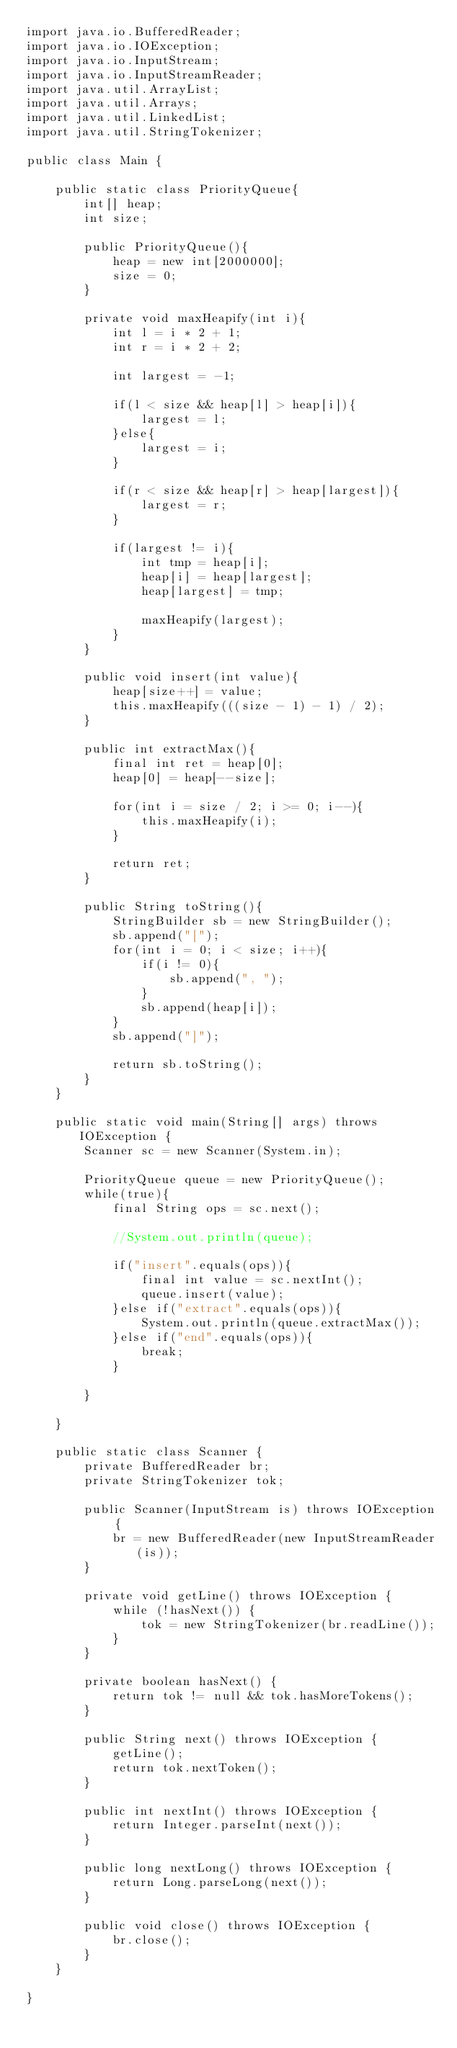<code> <loc_0><loc_0><loc_500><loc_500><_Java_>import java.io.BufferedReader;
import java.io.IOException;
import java.io.InputStream;
import java.io.InputStreamReader;
import java.util.ArrayList;
import java.util.Arrays;
import java.util.LinkedList;
import java.util.StringTokenizer;

public class Main {
	
	public static class PriorityQueue{
		int[] heap;
		int size;
		
		public PriorityQueue(){
			heap = new int[2000000];
			size = 0;
		}
		
		private void maxHeapify(int i){
			int l = i * 2 + 1;
			int r = i * 2 + 2;
		
			int largest = -1;
		
			if(l < size && heap[l] > heap[i]){
				largest = l;
			}else{
				largest = i;
			}
		
			if(r < size && heap[r] > heap[largest]){
				largest = r;
			}
		
			if(largest != i){
				int tmp = heap[i];
				heap[i] = heap[largest];
				heap[largest] = tmp;
			
				maxHeapify(largest);
			}
		}
		
		public void insert(int value){
			heap[size++] = value;
			this.maxHeapify(((size - 1) - 1) / 2);
		}
		
		public int extractMax(){
			final int ret = heap[0];
			heap[0] = heap[--size]; 
			
			for(int i = size / 2; i >= 0; i--){
				this.maxHeapify(i);
			}
			
			return ret;
		}
		
		public String toString(){
			StringBuilder sb = new StringBuilder();
			sb.append("[");
			for(int i = 0; i < size; i++){
				if(i != 0){
					sb.append(", ");
				}
				sb.append(heap[i]);
			}
			sb.append("]");
		
			return sb.toString();
		}
	}
	
	public static void main(String[] args) throws IOException {
		Scanner sc = new Scanner(System.in);
		
		PriorityQueue queue = new PriorityQueue();
		while(true){
			final String ops = sc.next();
			
			//System.out.println(queue);
			
			if("insert".equals(ops)){
				final int value = sc.nextInt();
				queue.insert(value);
			}else if("extract".equals(ops)){
				System.out.println(queue.extractMax());
			}else if("end".equals(ops)){
				break;
			}
			
		}
		
	}

	public static class Scanner {
		private BufferedReader br;
		private StringTokenizer tok;

		public Scanner(InputStream is) throws IOException {
			br = new BufferedReader(new InputStreamReader(is));
		}

		private void getLine() throws IOException {
			while (!hasNext()) {
				tok = new StringTokenizer(br.readLine());
			}
		}

		private boolean hasNext() {
			return tok != null && tok.hasMoreTokens();
		}

		public String next() throws IOException {
			getLine();
			return tok.nextToken();
		}

		public int nextInt() throws IOException {
			return Integer.parseInt(next());
		}

		public long nextLong() throws IOException {
			return Long.parseLong(next());
		}

		public void close() throws IOException {
			br.close();
		}
	}

}</code> 